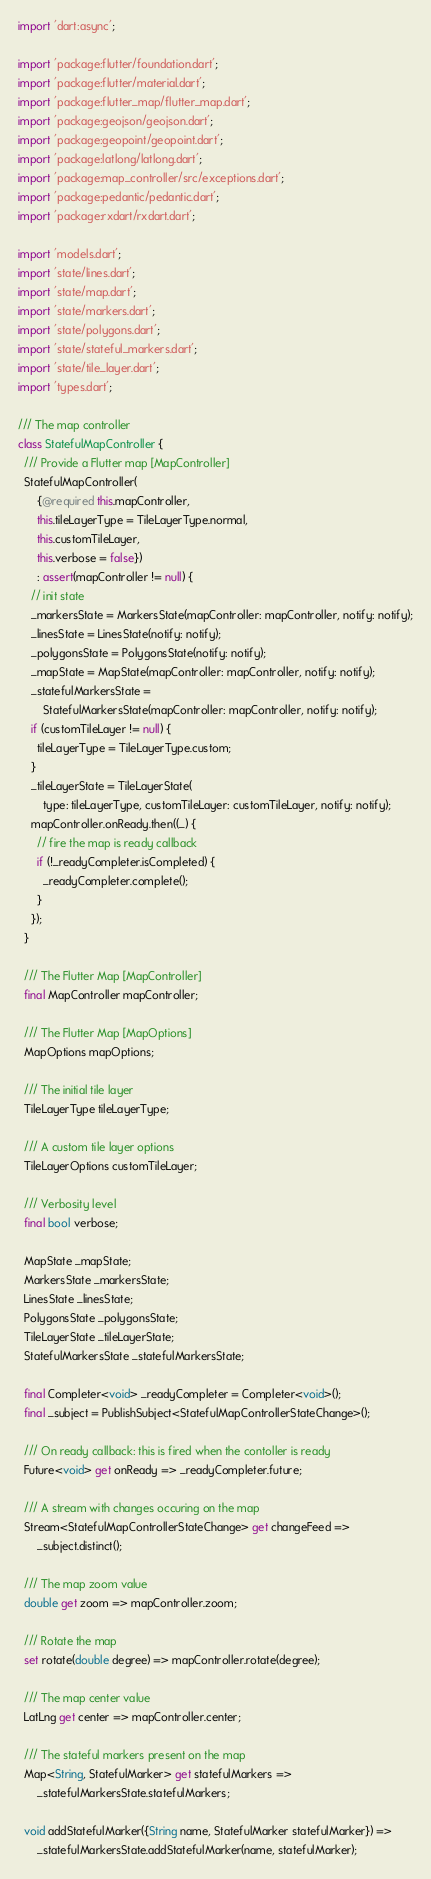Convert code to text. <code><loc_0><loc_0><loc_500><loc_500><_Dart_>import 'dart:async';

import 'package:flutter/foundation.dart';
import 'package:flutter/material.dart';
import 'package:flutter_map/flutter_map.dart';
import 'package:geojson/geojson.dart';
import 'package:geopoint/geopoint.dart';
import 'package:latlong/latlong.dart';
import 'package:map_controller/src/exceptions.dart';
import 'package:pedantic/pedantic.dart';
import 'package:rxdart/rxdart.dart';

import 'models.dart';
import 'state/lines.dart';
import 'state/map.dart';
import 'state/markers.dart';
import 'state/polygons.dart';
import 'state/stateful_markers.dart';
import 'state/tile_layer.dart';
import 'types.dart';

/// The map controller
class StatefulMapController {
  /// Provide a Flutter map [MapController]
  StatefulMapController(
      {@required this.mapController,
      this.tileLayerType = TileLayerType.normal,
      this.customTileLayer,
      this.verbose = false})
      : assert(mapController != null) {
    // init state
    _markersState = MarkersState(mapController: mapController, notify: notify);
    _linesState = LinesState(notify: notify);
    _polygonsState = PolygonsState(notify: notify);
    _mapState = MapState(mapController: mapController, notify: notify);
    _statefulMarkersState =
        StatefulMarkersState(mapController: mapController, notify: notify);
    if (customTileLayer != null) {
      tileLayerType = TileLayerType.custom;
    }
    _tileLayerState = TileLayerState(
        type: tileLayerType, customTileLayer: customTileLayer, notify: notify);
    mapController.onReady.then((_) {
      // fire the map is ready callback
      if (!_readyCompleter.isCompleted) {
        _readyCompleter.complete();
      }
    });
  }

  /// The Flutter Map [MapController]
  final MapController mapController;

  /// The Flutter Map [MapOptions]
  MapOptions mapOptions;

  /// The initial tile layer
  TileLayerType tileLayerType;

  /// A custom tile layer options
  TileLayerOptions customTileLayer;

  /// Verbosity level
  final bool verbose;

  MapState _mapState;
  MarkersState _markersState;
  LinesState _linesState;
  PolygonsState _polygonsState;
  TileLayerState _tileLayerState;
  StatefulMarkersState _statefulMarkersState;

  final Completer<void> _readyCompleter = Completer<void>();
  final _subject = PublishSubject<StatefulMapControllerStateChange>();

  /// On ready callback: this is fired when the contoller is ready
  Future<void> get onReady => _readyCompleter.future;

  /// A stream with changes occuring on the map
  Stream<StatefulMapControllerStateChange> get changeFeed =>
      _subject.distinct();

  /// The map zoom value
  double get zoom => mapController.zoom;

  /// Rotate the map
  set rotate(double degree) => mapController.rotate(degree);

  /// The map center value
  LatLng get center => mapController.center;

  /// The stateful markers present on the map
  Map<String, StatefulMarker> get statefulMarkers =>
      _statefulMarkersState.statefulMarkers;

  void addStatefulMarker({String name, StatefulMarker statefulMarker}) =>
      _statefulMarkersState.addStatefulMarker(name, statefulMarker);
</code> 